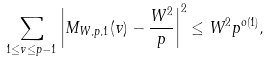<formula> <loc_0><loc_0><loc_500><loc_500>\sum _ { 1 \leq v \leq p - 1 } \left | M _ { W , p , 1 } ( v ) - \frac { W ^ { 2 } } { p } \right | ^ { 2 } \leq W ^ { 2 } p ^ { o ( 1 ) } ,</formula> 